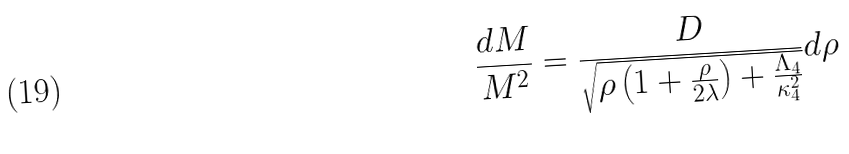Convert formula to latex. <formula><loc_0><loc_0><loc_500><loc_500>\frac { d M } { M ^ { 2 } } = \frac { D } { \sqrt { \rho \left ( 1 + \frac { \rho } { 2 \lambda } \right ) + \frac { \Lambda _ { 4 } } { \kappa _ { 4 } ^ { 2 } } } } d \rho</formula> 